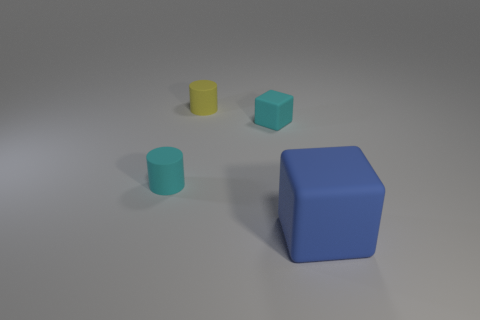Add 3 big rubber objects. How many objects exist? 7 Add 4 yellow matte cylinders. How many yellow matte cylinders exist? 5 Subtract 1 yellow cylinders. How many objects are left? 3 Subtract all large gray metal balls. Subtract all cyan rubber blocks. How many objects are left? 3 Add 4 rubber blocks. How many rubber blocks are left? 6 